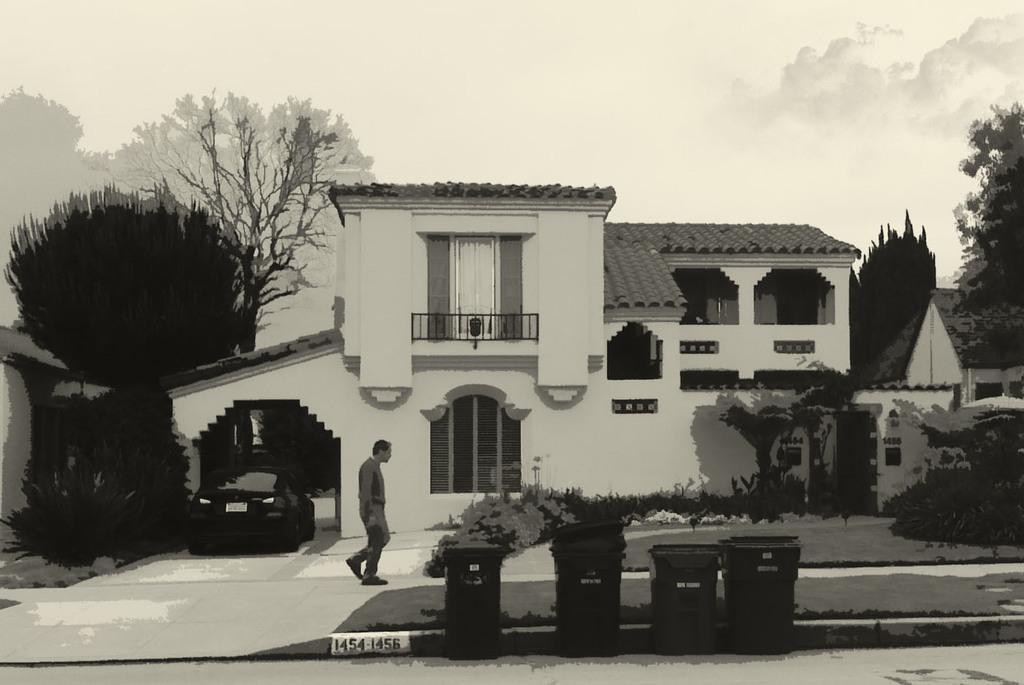In one or two sentences, can you explain what this image depicts? It is an editing picture. In the center of the image we can see the sky,clouds,trees,pillars,dustbins,one building,wall,roof,door,window,one vehicle,one person standing and a few other objects. 